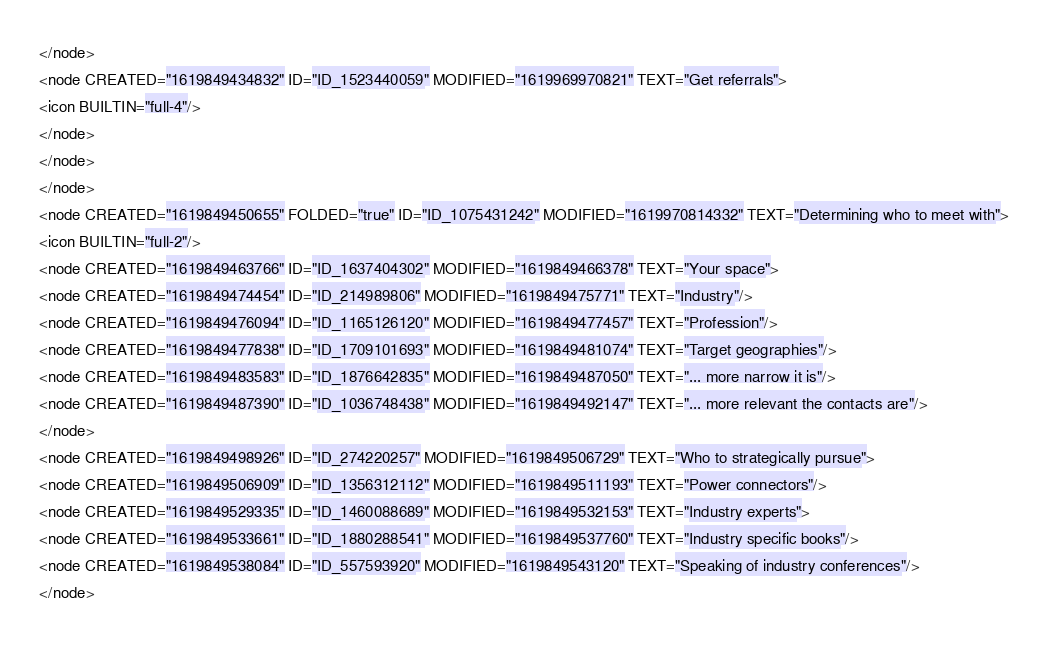Convert code to text. <code><loc_0><loc_0><loc_500><loc_500><_ObjectiveC_></node>
<node CREATED="1619849434832" ID="ID_1523440059" MODIFIED="1619969970821" TEXT="Get referrals">
<icon BUILTIN="full-4"/>
</node>
</node>
</node>
<node CREATED="1619849450655" FOLDED="true" ID="ID_1075431242" MODIFIED="1619970814332" TEXT="Determining who to meet with">
<icon BUILTIN="full-2"/>
<node CREATED="1619849463766" ID="ID_1637404302" MODIFIED="1619849466378" TEXT="Your space">
<node CREATED="1619849474454" ID="ID_214989806" MODIFIED="1619849475771" TEXT="Industry"/>
<node CREATED="1619849476094" ID="ID_1165126120" MODIFIED="1619849477457" TEXT="Profession"/>
<node CREATED="1619849477838" ID="ID_1709101693" MODIFIED="1619849481074" TEXT="Target geographies"/>
<node CREATED="1619849483583" ID="ID_1876642835" MODIFIED="1619849487050" TEXT="... more narrow it is"/>
<node CREATED="1619849487390" ID="ID_1036748438" MODIFIED="1619849492147" TEXT="... more relevant the contacts are"/>
</node>
<node CREATED="1619849498926" ID="ID_274220257" MODIFIED="1619849506729" TEXT="Who to strategically pursue">
<node CREATED="1619849506909" ID="ID_1356312112" MODIFIED="1619849511193" TEXT="Power connectors"/>
<node CREATED="1619849529335" ID="ID_1460088689" MODIFIED="1619849532153" TEXT="Industry experts">
<node CREATED="1619849533661" ID="ID_1880288541" MODIFIED="1619849537760" TEXT="Industry specific books"/>
<node CREATED="1619849538084" ID="ID_557593920" MODIFIED="1619849543120" TEXT="Speaking of industry conferences"/>
</node></code> 